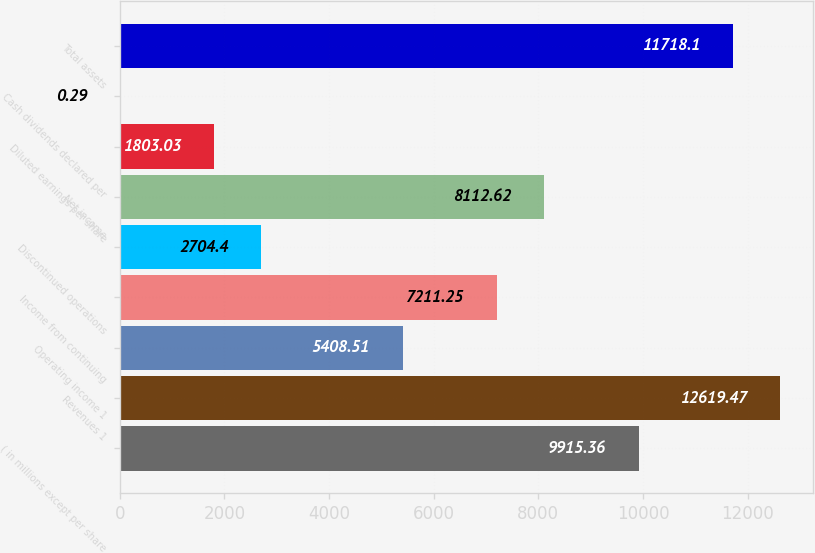Convert chart to OTSL. <chart><loc_0><loc_0><loc_500><loc_500><bar_chart><fcel>( in millions except per share<fcel>Revenues 1<fcel>Operating income 1<fcel>Income from continuing<fcel>Discontinued operations<fcel>Net income<fcel>Diluted earnings per share<fcel>Cash dividends declared per<fcel>Total assets<nl><fcel>9915.36<fcel>12619.5<fcel>5408.51<fcel>7211.25<fcel>2704.4<fcel>8112.62<fcel>1803.03<fcel>0.29<fcel>11718.1<nl></chart> 